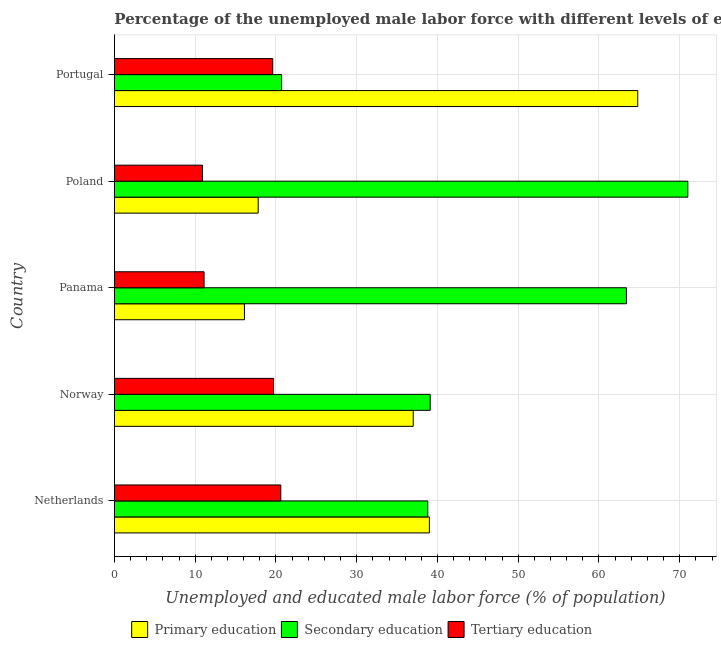How many different coloured bars are there?
Give a very brief answer. 3. Are the number of bars on each tick of the Y-axis equal?
Offer a very short reply. Yes. How many bars are there on the 5th tick from the bottom?
Your answer should be very brief. 3. In how many cases, is the number of bars for a given country not equal to the number of legend labels?
Provide a short and direct response. 0. What is the percentage of male labor force who received secondary education in Poland?
Make the answer very short. 71. Across all countries, what is the minimum percentage of male labor force who received secondary education?
Your response must be concise. 20.7. In which country was the percentage of male labor force who received secondary education maximum?
Give a very brief answer. Poland. In which country was the percentage of male labor force who received primary education minimum?
Ensure brevity in your answer.  Panama. What is the total percentage of male labor force who received primary education in the graph?
Your answer should be compact. 174.7. What is the difference between the percentage of male labor force who received tertiary education in Netherlands and that in Norway?
Your response must be concise. 0.9. What is the difference between the percentage of male labor force who received secondary education in Netherlands and the percentage of male labor force who received tertiary education in Portugal?
Your response must be concise. 19.2. What is the average percentage of male labor force who received secondary education per country?
Keep it short and to the point. 46.6. In how many countries, is the percentage of male labor force who received secondary education greater than 16 %?
Your answer should be very brief. 5. What is the ratio of the percentage of male labor force who received secondary education in Poland to that in Portugal?
Give a very brief answer. 3.43. What is the difference between the highest and the second highest percentage of male labor force who received primary education?
Give a very brief answer. 25.8. What is the difference between the highest and the lowest percentage of male labor force who received tertiary education?
Your response must be concise. 9.7. How many bars are there?
Your answer should be compact. 15. Does the graph contain any zero values?
Provide a short and direct response. No. What is the title of the graph?
Ensure brevity in your answer.  Percentage of the unemployed male labor force with different levels of education in countries. What is the label or title of the X-axis?
Your answer should be very brief. Unemployed and educated male labor force (% of population). What is the Unemployed and educated male labor force (% of population) in Secondary education in Netherlands?
Your answer should be very brief. 38.8. What is the Unemployed and educated male labor force (% of population) in Tertiary education in Netherlands?
Offer a terse response. 20.6. What is the Unemployed and educated male labor force (% of population) of Secondary education in Norway?
Give a very brief answer. 39.1. What is the Unemployed and educated male labor force (% of population) in Tertiary education in Norway?
Make the answer very short. 19.7. What is the Unemployed and educated male labor force (% of population) of Primary education in Panama?
Offer a very short reply. 16.1. What is the Unemployed and educated male labor force (% of population) of Secondary education in Panama?
Provide a short and direct response. 63.4. What is the Unemployed and educated male labor force (% of population) of Tertiary education in Panama?
Offer a very short reply. 11.1. What is the Unemployed and educated male labor force (% of population) of Primary education in Poland?
Your answer should be compact. 17.8. What is the Unemployed and educated male labor force (% of population) of Secondary education in Poland?
Your answer should be very brief. 71. What is the Unemployed and educated male labor force (% of population) of Tertiary education in Poland?
Provide a short and direct response. 10.9. What is the Unemployed and educated male labor force (% of population) in Primary education in Portugal?
Offer a terse response. 64.8. What is the Unemployed and educated male labor force (% of population) of Secondary education in Portugal?
Offer a terse response. 20.7. What is the Unemployed and educated male labor force (% of population) of Tertiary education in Portugal?
Ensure brevity in your answer.  19.6. Across all countries, what is the maximum Unemployed and educated male labor force (% of population) of Primary education?
Offer a very short reply. 64.8. Across all countries, what is the maximum Unemployed and educated male labor force (% of population) of Secondary education?
Ensure brevity in your answer.  71. Across all countries, what is the maximum Unemployed and educated male labor force (% of population) in Tertiary education?
Provide a short and direct response. 20.6. Across all countries, what is the minimum Unemployed and educated male labor force (% of population) in Primary education?
Your answer should be very brief. 16.1. Across all countries, what is the minimum Unemployed and educated male labor force (% of population) in Secondary education?
Make the answer very short. 20.7. Across all countries, what is the minimum Unemployed and educated male labor force (% of population) in Tertiary education?
Your response must be concise. 10.9. What is the total Unemployed and educated male labor force (% of population) of Primary education in the graph?
Keep it short and to the point. 174.7. What is the total Unemployed and educated male labor force (% of population) in Secondary education in the graph?
Provide a short and direct response. 233. What is the total Unemployed and educated male labor force (% of population) of Tertiary education in the graph?
Give a very brief answer. 81.9. What is the difference between the Unemployed and educated male labor force (% of population) of Secondary education in Netherlands and that in Norway?
Keep it short and to the point. -0.3. What is the difference between the Unemployed and educated male labor force (% of population) in Primary education in Netherlands and that in Panama?
Give a very brief answer. 22.9. What is the difference between the Unemployed and educated male labor force (% of population) in Secondary education in Netherlands and that in Panama?
Provide a short and direct response. -24.6. What is the difference between the Unemployed and educated male labor force (% of population) in Primary education in Netherlands and that in Poland?
Ensure brevity in your answer.  21.2. What is the difference between the Unemployed and educated male labor force (% of population) of Secondary education in Netherlands and that in Poland?
Your answer should be very brief. -32.2. What is the difference between the Unemployed and educated male labor force (% of population) of Tertiary education in Netherlands and that in Poland?
Offer a terse response. 9.7. What is the difference between the Unemployed and educated male labor force (% of population) in Primary education in Netherlands and that in Portugal?
Your answer should be very brief. -25.8. What is the difference between the Unemployed and educated male labor force (% of population) in Primary education in Norway and that in Panama?
Give a very brief answer. 20.9. What is the difference between the Unemployed and educated male labor force (% of population) in Secondary education in Norway and that in Panama?
Offer a terse response. -24.3. What is the difference between the Unemployed and educated male labor force (% of population) in Primary education in Norway and that in Poland?
Give a very brief answer. 19.2. What is the difference between the Unemployed and educated male labor force (% of population) in Secondary education in Norway and that in Poland?
Your answer should be very brief. -31.9. What is the difference between the Unemployed and educated male labor force (% of population) in Tertiary education in Norway and that in Poland?
Make the answer very short. 8.8. What is the difference between the Unemployed and educated male labor force (% of population) in Primary education in Norway and that in Portugal?
Your answer should be very brief. -27.8. What is the difference between the Unemployed and educated male labor force (% of population) in Tertiary education in Norway and that in Portugal?
Ensure brevity in your answer.  0.1. What is the difference between the Unemployed and educated male labor force (% of population) in Secondary education in Panama and that in Poland?
Provide a succinct answer. -7.6. What is the difference between the Unemployed and educated male labor force (% of population) of Primary education in Panama and that in Portugal?
Ensure brevity in your answer.  -48.7. What is the difference between the Unemployed and educated male labor force (% of population) in Secondary education in Panama and that in Portugal?
Make the answer very short. 42.7. What is the difference between the Unemployed and educated male labor force (% of population) in Tertiary education in Panama and that in Portugal?
Your response must be concise. -8.5. What is the difference between the Unemployed and educated male labor force (% of population) of Primary education in Poland and that in Portugal?
Offer a very short reply. -47. What is the difference between the Unemployed and educated male labor force (% of population) in Secondary education in Poland and that in Portugal?
Your response must be concise. 50.3. What is the difference between the Unemployed and educated male labor force (% of population) in Tertiary education in Poland and that in Portugal?
Give a very brief answer. -8.7. What is the difference between the Unemployed and educated male labor force (% of population) in Primary education in Netherlands and the Unemployed and educated male labor force (% of population) in Tertiary education in Norway?
Offer a very short reply. 19.3. What is the difference between the Unemployed and educated male labor force (% of population) in Secondary education in Netherlands and the Unemployed and educated male labor force (% of population) in Tertiary education in Norway?
Provide a short and direct response. 19.1. What is the difference between the Unemployed and educated male labor force (% of population) in Primary education in Netherlands and the Unemployed and educated male labor force (% of population) in Secondary education in Panama?
Make the answer very short. -24.4. What is the difference between the Unemployed and educated male labor force (% of population) of Primary education in Netherlands and the Unemployed and educated male labor force (% of population) of Tertiary education in Panama?
Ensure brevity in your answer.  27.9. What is the difference between the Unemployed and educated male labor force (% of population) in Secondary education in Netherlands and the Unemployed and educated male labor force (% of population) in Tertiary education in Panama?
Your response must be concise. 27.7. What is the difference between the Unemployed and educated male labor force (% of population) in Primary education in Netherlands and the Unemployed and educated male labor force (% of population) in Secondary education in Poland?
Your answer should be compact. -32. What is the difference between the Unemployed and educated male labor force (% of population) of Primary education in Netherlands and the Unemployed and educated male labor force (% of population) of Tertiary education in Poland?
Your answer should be compact. 28.1. What is the difference between the Unemployed and educated male labor force (% of population) in Secondary education in Netherlands and the Unemployed and educated male labor force (% of population) in Tertiary education in Poland?
Your answer should be compact. 27.9. What is the difference between the Unemployed and educated male labor force (% of population) in Primary education in Netherlands and the Unemployed and educated male labor force (% of population) in Secondary education in Portugal?
Provide a short and direct response. 18.3. What is the difference between the Unemployed and educated male labor force (% of population) of Primary education in Norway and the Unemployed and educated male labor force (% of population) of Secondary education in Panama?
Ensure brevity in your answer.  -26.4. What is the difference between the Unemployed and educated male labor force (% of population) of Primary education in Norway and the Unemployed and educated male labor force (% of population) of Tertiary education in Panama?
Provide a short and direct response. 25.9. What is the difference between the Unemployed and educated male labor force (% of population) in Secondary education in Norway and the Unemployed and educated male labor force (% of population) in Tertiary education in Panama?
Provide a short and direct response. 28. What is the difference between the Unemployed and educated male labor force (% of population) of Primary education in Norway and the Unemployed and educated male labor force (% of population) of Secondary education in Poland?
Your response must be concise. -34. What is the difference between the Unemployed and educated male labor force (% of population) in Primary education in Norway and the Unemployed and educated male labor force (% of population) in Tertiary education in Poland?
Keep it short and to the point. 26.1. What is the difference between the Unemployed and educated male labor force (% of population) of Secondary education in Norway and the Unemployed and educated male labor force (% of population) of Tertiary education in Poland?
Keep it short and to the point. 28.2. What is the difference between the Unemployed and educated male labor force (% of population) of Primary education in Norway and the Unemployed and educated male labor force (% of population) of Secondary education in Portugal?
Offer a terse response. 16.3. What is the difference between the Unemployed and educated male labor force (% of population) of Primary education in Panama and the Unemployed and educated male labor force (% of population) of Secondary education in Poland?
Make the answer very short. -54.9. What is the difference between the Unemployed and educated male labor force (% of population) of Primary education in Panama and the Unemployed and educated male labor force (% of population) of Tertiary education in Poland?
Provide a short and direct response. 5.2. What is the difference between the Unemployed and educated male labor force (% of population) in Secondary education in Panama and the Unemployed and educated male labor force (% of population) in Tertiary education in Poland?
Your answer should be very brief. 52.5. What is the difference between the Unemployed and educated male labor force (% of population) in Primary education in Panama and the Unemployed and educated male labor force (% of population) in Tertiary education in Portugal?
Ensure brevity in your answer.  -3.5. What is the difference between the Unemployed and educated male labor force (% of population) of Secondary education in Panama and the Unemployed and educated male labor force (% of population) of Tertiary education in Portugal?
Your answer should be very brief. 43.8. What is the difference between the Unemployed and educated male labor force (% of population) in Primary education in Poland and the Unemployed and educated male labor force (% of population) in Secondary education in Portugal?
Offer a very short reply. -2.9. What is the difference between the Unemployed and educated male labor force (% of population) in Secondary education in Poland and the Unemployed and educated male labor force (% of population) in Tertiary education in Portugal?
Offer a very short reply. 51.4. What is the average Unemployed and educated male labor force (% of population) of Primary education per country?
Offer a very short reply. 34.94. What is the average Unemployed and educated male labor force (% of population) of Secondary education per country?
Offer a terse response. 46.6. What is the average Unemployed and educated male labor force (% of population) in Tertiary education per country?
Provide a succinct answer. 16.38. What is the difference between the Unemployed and educated male labor force (% of population) in Secondary education and Unemployed and educated male labor force (% of population) in Tertiary education in Netherlands?
Give a very brief answer. 18.2. What is the difference between the Unemployed and educated male labor force (% of population) of Primary education and Unemployed and educated male labor force (% of population) of Secondary education in Panama?
Provide a short and direct response. -47.3. What is the difference between the Unemployed and educated male labor force (% of population) in Secondary education and Unemployed and educated male labor force (% of population) in Tertiary education in Panama?
Your answer should be compact. 52.3. What is the difference between the Unemployed and educated male labor force (% of population) of Primary education and Unemployed and educated male labor force (% of population) of Secondary education in Poland?
Provide a succinct answer. -53.2. What is the difference between the Unemployed and educated male labor force (% of population) in Primary education and Unemployed and educated male labor force (% of population) in Tertiary education in Poland?
Your answer should be very brief. 6.9. What is the difference between the Unemployed and educated male labor force (% of population) of Secondary education and Unemployed and educated male labor force (% of population) of Tertiary education in Poland?
Give a very brief answer. 60.1. What is the difference between the Unemployed and educated male labor force (% of population) in Primary education and Unemployed and educated male labor force (% of population) in Secondary education in Portugal?
Offer a very short reply. 44.1. What is the difference between the Unemployed and educated male labor force (% of population) in Primary education and Unemployed and educated male labor force (% of population) in Tertiary education in Portugal?
Make the answer very short. 45.2. What is the ratio of the Unemployed and educated male labor force (% of population) of Primary education in Netherlands to that in Norway?
Your answer should be compact. 1.05. What is the ratio of the Unemployed and educated male labor force (% of population) in Secondary education in Netherlands to that in Norway?
Your response must be concise. 0.99. What is the ratio of the Unemployed and educated male labor force (% of population) of Tertiary education in Netherlands to that in Norway?
Offer a very short reply. 1.05. What is the ratio of the Unemployed and educated male labor force (% of population) of Primary education in Netherlands to that in Panama?
Ensure brevity in your answer.  2.42. What is the ratio of the Unemployed and educated male labor force (% of population) in Secondary education in Netherlands to that in Panama?
Offer a very short reply. 0.61. What is the ratio of the Unemployed and educated male labor force (% of population) of Tertiary education in Netherlands to that in Panama?
Your answer should be compact. 1.86. What is the ratio of the Unemployed and educated male labor force (% of population) in Primary education in Netherlands to that in Poland?
Make the answer very short. 2.19. What is the ratio of the Unemployed and educated male labor force (% of population) of Secondary education in Netherlands to that in Poland?
Provide a short and direct response. 0.55. What is the ratio of the Unemployed and educated male labor force (% of population) of Tertiary education in Netherlands to that in Poland?
Your answer should be compact. 1.89. What is the ratio of the Unemployed and educated male labor force (% of population) of Primary education in Netherlands to that in Portugal?
Your answer should be very brief. 0.6. What is the ratio of the Unemployed and educated male labor force (% of population) in Secondary education in Netherlands to that in Portugal?
Ensure brevity in your answer.  1.87. What is the ratio of the Unemployed and educated male labor force (% of population) of Tertiary education in Netherlands to that in Portugal?
Offer a terse response. 1.05. What is the ratio of the Unemployed and educated male labor force (% of population) in Primary education in Norway to that in Panama?
Make the answer very short. 2.3. What is the ratio of the Unemployed and educated male labor force (% of population) in Secondary education in Norway to that in Panama?
Offer a very short reply. 0.62. What is the ratio of the Unemployed and educated male labor force (% of population) of Tertiary education in Norway to that in Panama?
Keep it short and to the point. 1.77. What is the ratio of the Unemployed and educated male labor force (% of population) of Primary education in Norway to that in Poland?
Provide a succinct answer. 2.08. What is the ratio of the Unemployed and educated male labor force (% of population) of Secondary education in Norway to that in Poland?
Your answer should be compact. 0.55. What is the ratio of the Unemployed and educated male labor force (% of population) of Tertiary education in Norway to that in Poland?
Keep it short and to the point. 1.81. What is the ratio of the Unemployed and educated male labor force (% of population) in Primary education in Norway to that in Portugal?
Offer a terse response. 0.57. What is the ratio of the Unemployed and educated male labor force (% of population) of Secondary education in Norway to that in Portugal?
Ensure brevity in your answer.  1.89. What is the ratio of the Unemployed and educated male labor force (% of population) in Primary education in Panama to that in Poland?
Ensure brevity in your answer.  0.9. What is the ratio of the Unemployed and educated male labor force (% of population) of Secondary education in Panama to that in Poland?
Offer a terse response. 0.89. What is the ratio of the Unemployed and educated male labor force (% of population) of Tertiary education in Panama to that in Poland?
Give a very brief answer. 1.02. What is the ratio of the Unemployed and educated male labor force (% of population) in Primary education in Panama to that in Portugal?
Make the answer very short. 0.25. What is the ratio of the Unemployed and educated male labor force (% of population) of Secondary education in Panama to that in Portugal?
Keep it short and to the point. 3.06. What is the ratio of the Unemployed and educated male labor force (% of population) in Tertiary education in Panama to that in Portugal?
Ensure brevity in your answer.  0.57. What is the ratio of the Unemployed and educated male labor force (% of population) in Primary education in Poland to that in Portugal?
Your answer should be compact. 0.27. What is the ratio of the Unemployed and educated male labor force (% of population) in Secondary education in Poland to that in Portugal?
Give a very brief answer. 3.43. What is the ratio of the Unemployed and educated male labor force (% of population) in Tertiary education in Poland to that in Portugal?
Your answer should be very brief. 0.56. What is the difference between the highest and the second highest Unemployed and educated male labor force (% of population) in Primary education?
Provide a succinct answer. 25.8. What is the difference between the highest and the second highest Unemployed and educated male labor force (% of population) of Secondary education?
Your answer should be compact. 7.6. What is the difference between the highest and the lowest Unemployed and educated male labor force (% of population) in Primary education?
Make the answer very short. 48.7. What is the difference between the highest and the lowest Unemployed and educated male labor force (% of population) in Secondary education?
Your answer should be compact. 50.3. What is the difference between the highest and the lowest Unemployed and educated male labor force (% of population) in Tertiary education?
Your answer should be very brief. 9.7. 